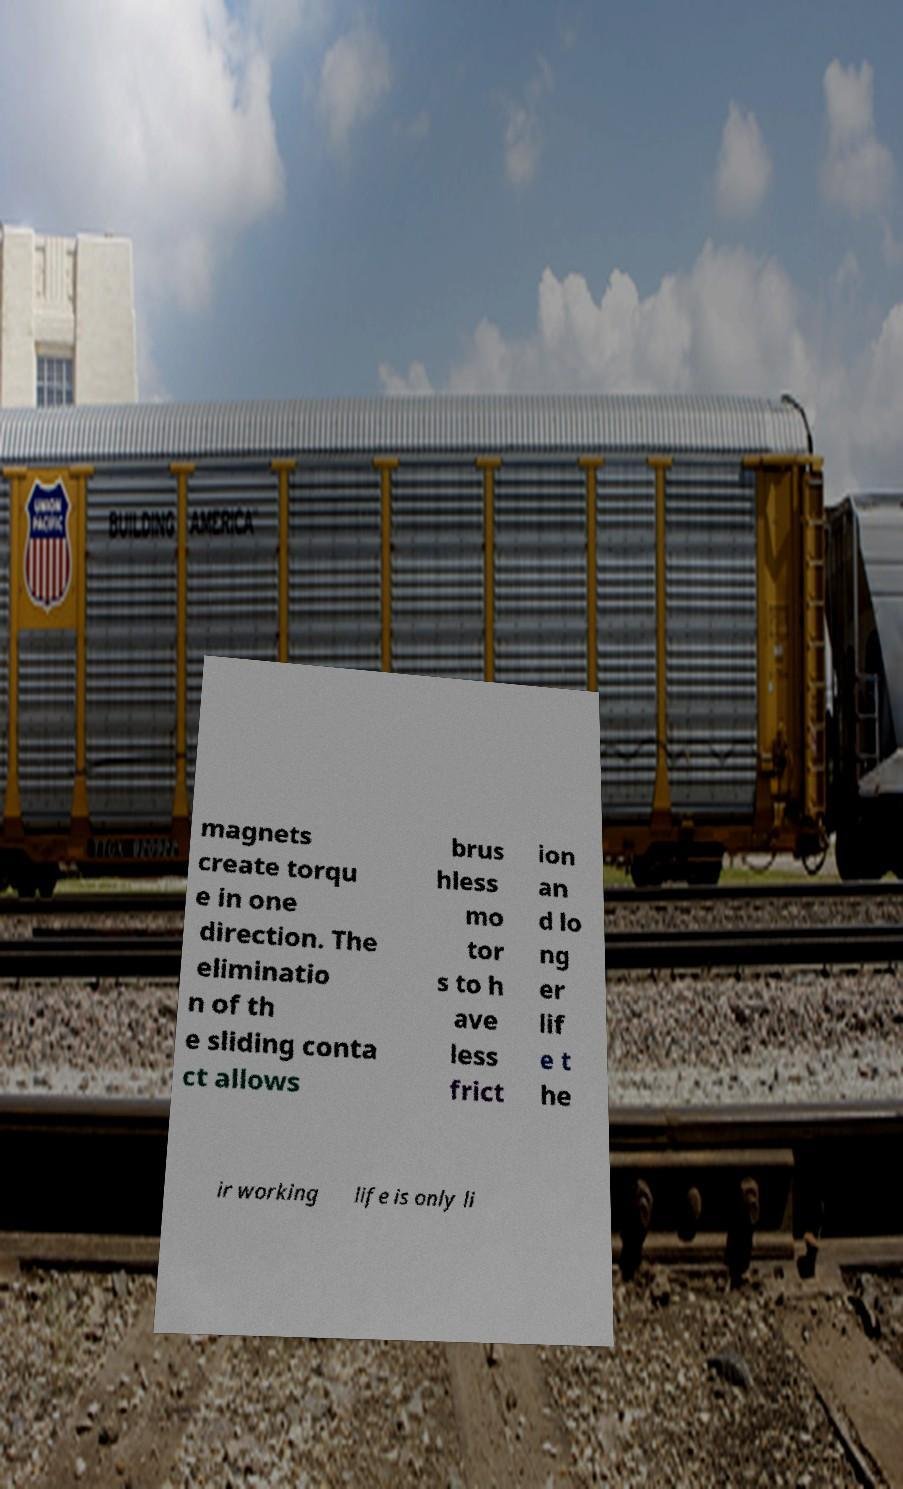What messages or text are displayed in this image? I need them in a readable, typed format. magnets create torqu e in one direction. The eliminatio n of th e sliding conta ct allows brus hless mo tor s to h ave less frict ion an d lo ng er lif e t he ir working life is only li 